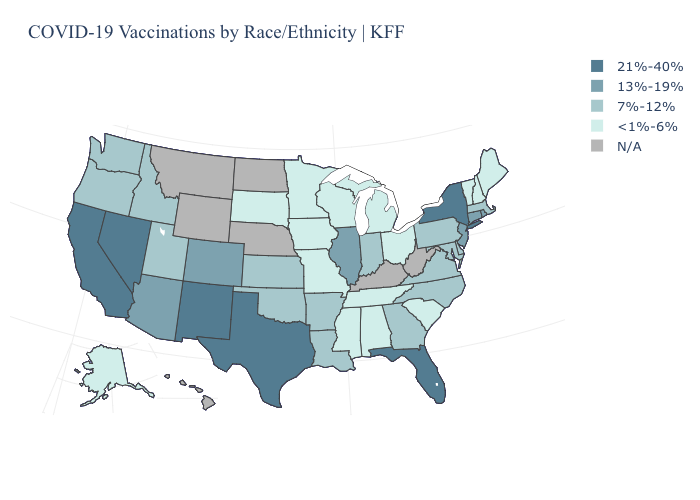Does New York have the highest value in the Northeast?
Short answer required. Yes. Name the states that have a value in the range 21%-40%?
Give a very brief answer. California, Florida, Nevada, New Mexico, New York, Texas. What is the lowest value in the USA?
Write a very short answer. <1%-6%. Name the states that have a value in the range 7%-12%?
Quick response, please. Arkansas, Delaware, Georgia, Idaho, Indiana, Kansas, Louisiana, Maryland, Massachusetts, North Carolina, Oklahoma, Oregon, Pennsylvania, Utah, Virginia, Washington. What is the lowest value in states that border Florida?
Write a very short answer. <1%-6%. Name the states that have a value in the range 21%-40%?
Quick response, please. California, Florida, Nevada, New Mexico, New York, Texas. What is the lowest value in states that border Illinois?
Concise answer only. <1%-6%. Which states hav the highest value in the Northeast?
Write a very short answer. New York. Which states hav the highest value in the MidWest?
Short answer required. Illinois. Name the states that have a value in the range 21%-40%?
Quick response, please. California, Florida, Nevada, New Mexico, New York, Texas. Does the map have missing data?
Quick response, please. Yes. What is the value of North Carolina?
Keep it brief. 7%-12%. Does the first symbol in the legend represent the smallest category?
Answer briefly. No. 